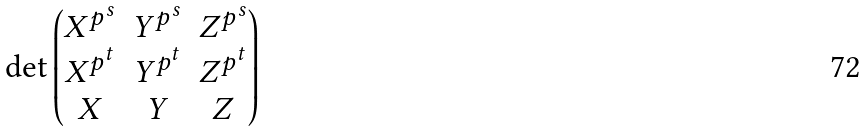Convert formula to latex. <formula><loc_0><loc_0><loc_500><loc_500>\det \begin{pmatrix} X ^ { p ^ { s } } & Y ^ { p ^ { s } } & Z ^ { p ^ { s } } \\ X ^ { p ^ { t } } & Y ^ { p ^ { t } } & Z ^ { p ^ { t } } \\ X & Y & Z \end{pmatrix}</formula> 